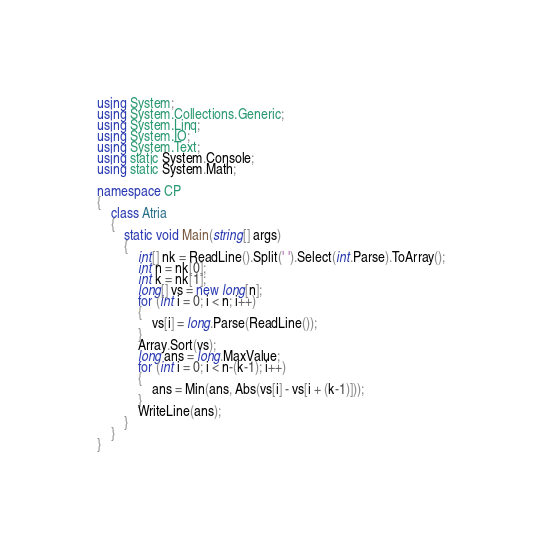<code> <loc_0><loc_0><loc_500><loc_500><_C#_>
using System;
using System.Collections.Generic;
using System.Linq;
using System.IO;
using System.Text;
using static System.Console;
using static System.Math;

namespace CP
{
    class Atria
    {
        static void Main(string[] args)
        {
            int[] nk = ReadLine().Split(' ').Select(int.Parse).ToArray();
            int n = nk[0];
            int k = nk[1];
            long[] vs = new long[n];
            for (int i = 0; i < n; i++)
            {
                vs[i] = long.Parse(ReadLine());
            }
            Array.Sort(vs);
            long ans = long.MaxValue;
            for (int i = 0; i < n-(k-1); i++)
            {
                ans = Min(ans, Abs(vs[i] - vs[i + (k-1)]));
            }
            WriteLine(ans);
        }
    }
}</code> 